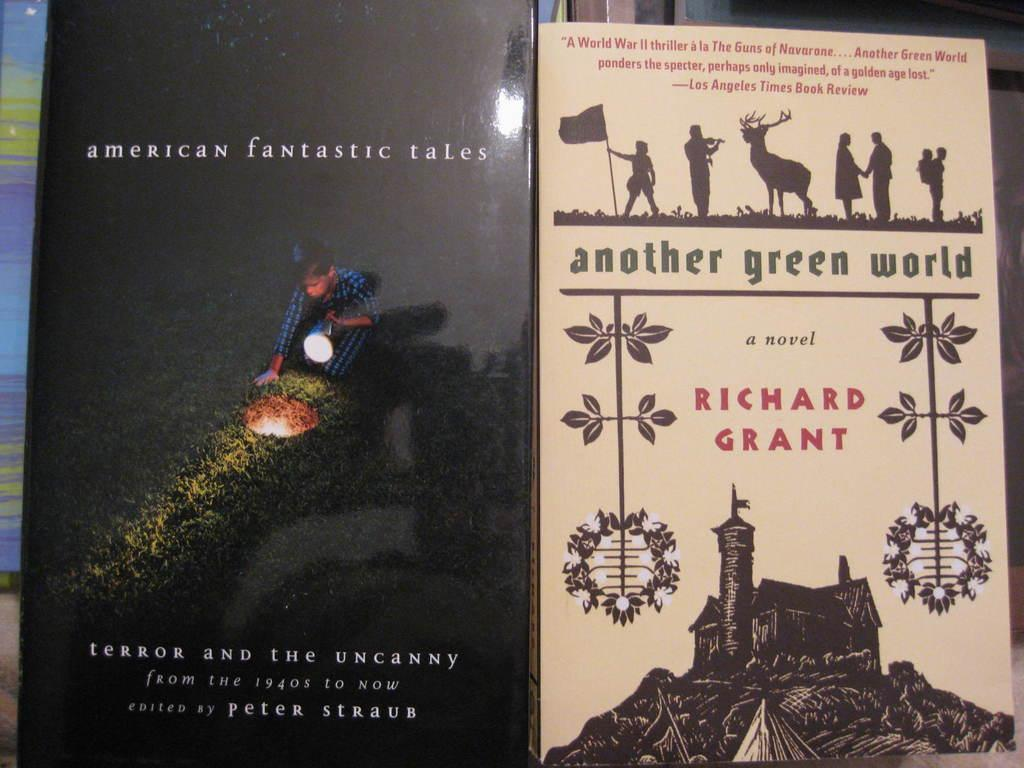<image>
Write a terse but informative summary of the picture. Two books next to each other, American Fantasy tales and Another Green World. 